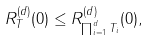Convert formula to latex. <formula><loc_0><loc_0><loc_500><loc_500>R ^ { ( d ) } _ { T } ( 0 ) \leq R ^ { ( d ) } _ { \prod _ { i = 1 } ^ { d } T _ { i } } ( 0 ) ,</formula> 